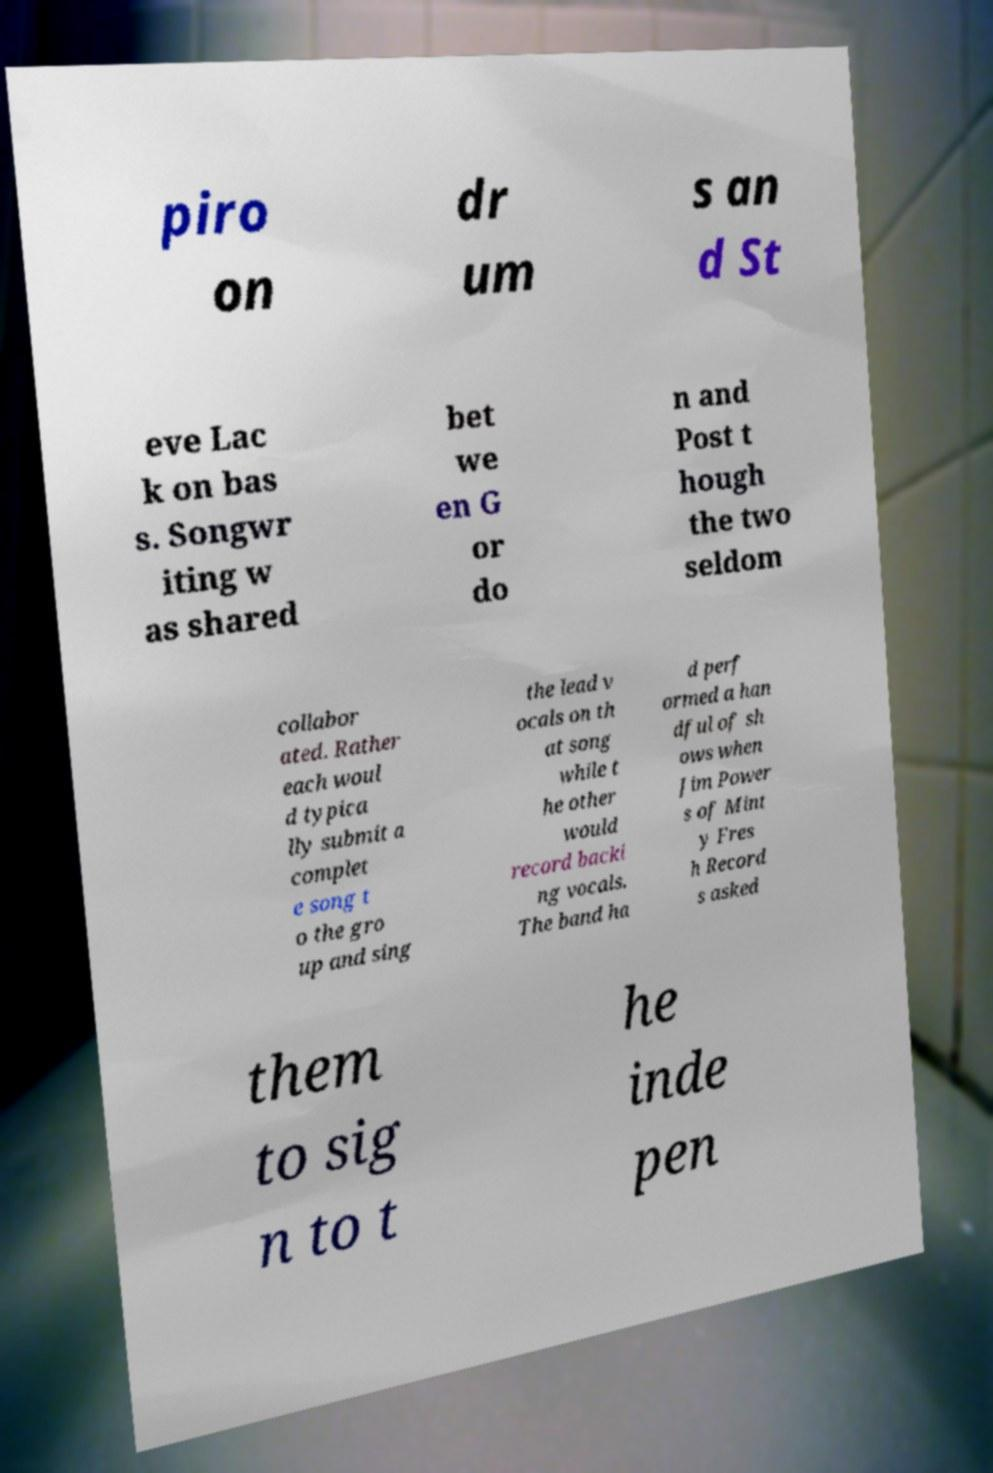There's text embedded in this image that I need extracted. Can you transcribe it verbatim? piro on dr um s an d St eve Lac k on bas s. Songwr iting w as shared bet we en G or do n and Post t hough the two seldom collabor ated. Rather each woul d typica lly submit a complet e song t o the gro up and sing the lead v ocals on th at song while t he other would record backi ng vocals. The band ha d perf ormed a han dful of sh ows when Jim Power s of Mint y Fres h Record s asked them to sig n to t he inde pen 